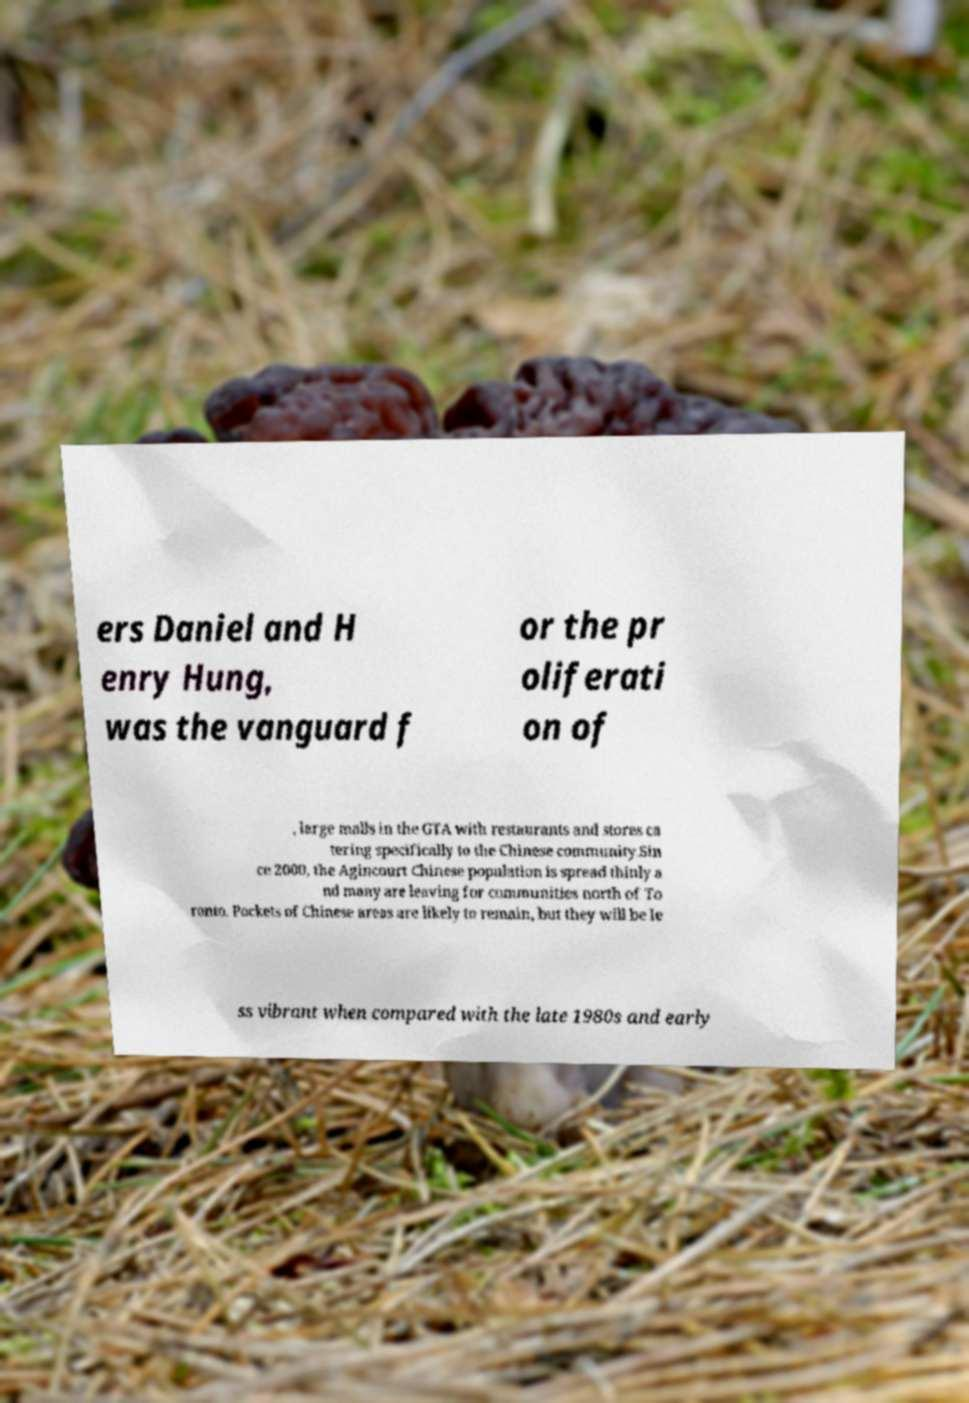Could you assist in decoding the text presented in this image and type it out clearly? ers Daniel and H enry Hung, was the vanguard f or the pr oliferati on of , large malls in the GTA with restaurants and stores ca tering specifically to the Chinese community.Sin ce 2000, the Agincourt Chinese population is spread thinly a nd many are leaving for communities north of To ronto. Pockets of Chinese areas are likely to remain, but they will be le ss vibrant when compared with the late 1980s and early 